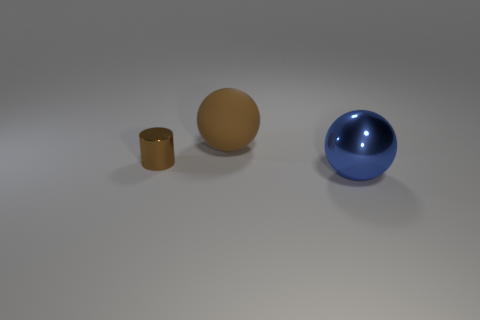Add 3 small gray rubber balls. How many objects exist? 6 Subtract all cylinders. How many objects are left? 2 Add 2 metal cylinders. How many metal cylinders are left? 3 Add 1 large yellow cylinders. How many large yellow cylinders exist? 1 Subtract 1 brown spheres. How many objects are left? 2 Subtract all purple objects. Subtract all tiny brown things. How many objects are left? 2 